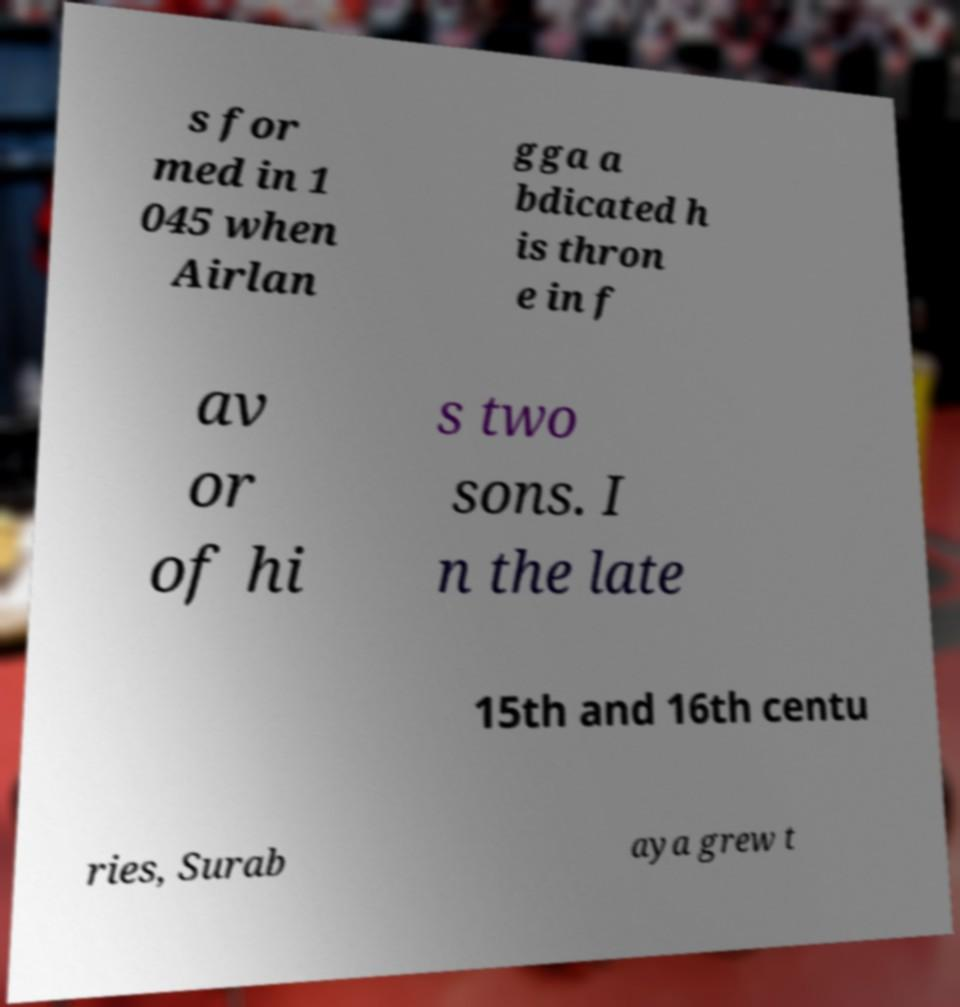For documentation purposes, I need the text within this image transcribed. Could you provide that? s for med in 1 045 when Airlan gga a bdicated h is thron e in f av or of hi s two sons. I n the late 15th and 16th centu ries, Surab aya grew t 